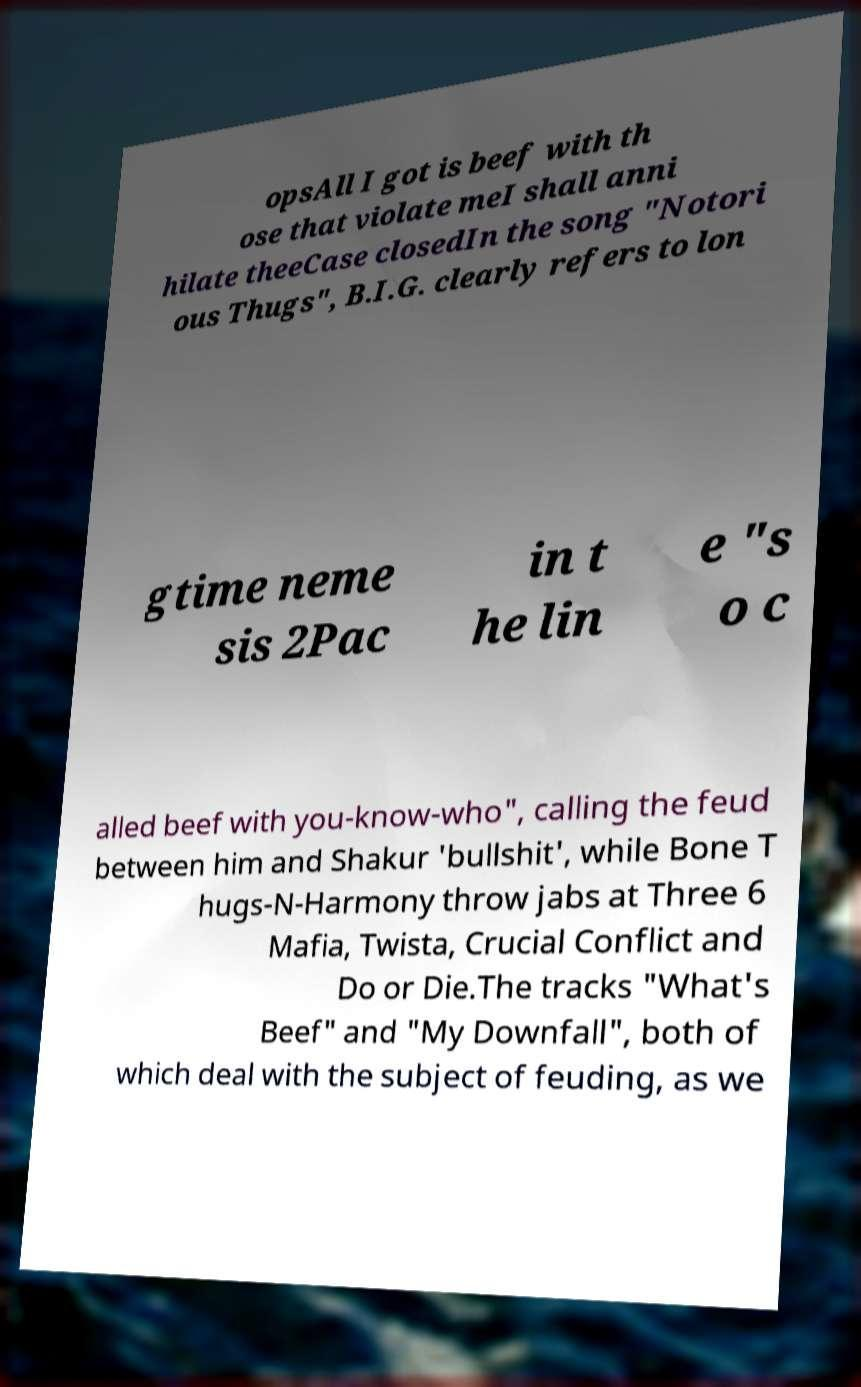I need the written content from this picture converted into text. Can you do that? opsAll I got is beef with th ose that violate meI shall anni hilate theeCase closedIn the song "Notori ous Thugs", B.I.G. clearly refers to lon gtime neme sis 2Pac in t he lin e "s o c alled beef with you-know-who", calling the feud between him and Shakur 'bullshit', while Bone T hugs-N-Harmony throw jabs at Three 6 Mafia, Twista, Crucial Conflict and Do or Die.The tracks "What's Beef" and "My Downfall", both of which deal with the subject of feuding, as we 